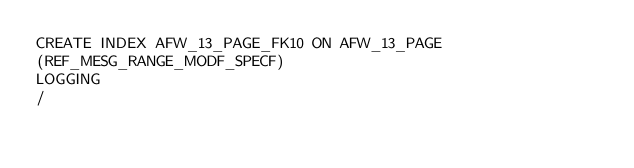Convert code to text. <code><loc_0><loc_0><loc_500><loc_500><_SQL_>CREATE INDEX AFW_13_PAGE_FK10 ON AFW_13_PAGE
(REF_MESG_RANGE_MODF_SPECF)
LOGGING
/
</code> 